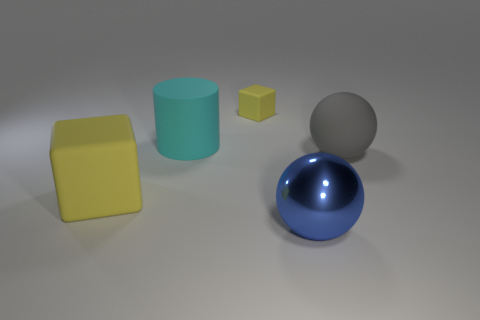Is the color of the tiny rubber block the same as the ball on the right side of the large shiny sphere? No, the tiny rubber block is yellow, whereas the ball on the right side of the large shiny sphere is blue. They are distinct not only in size but also in color. 